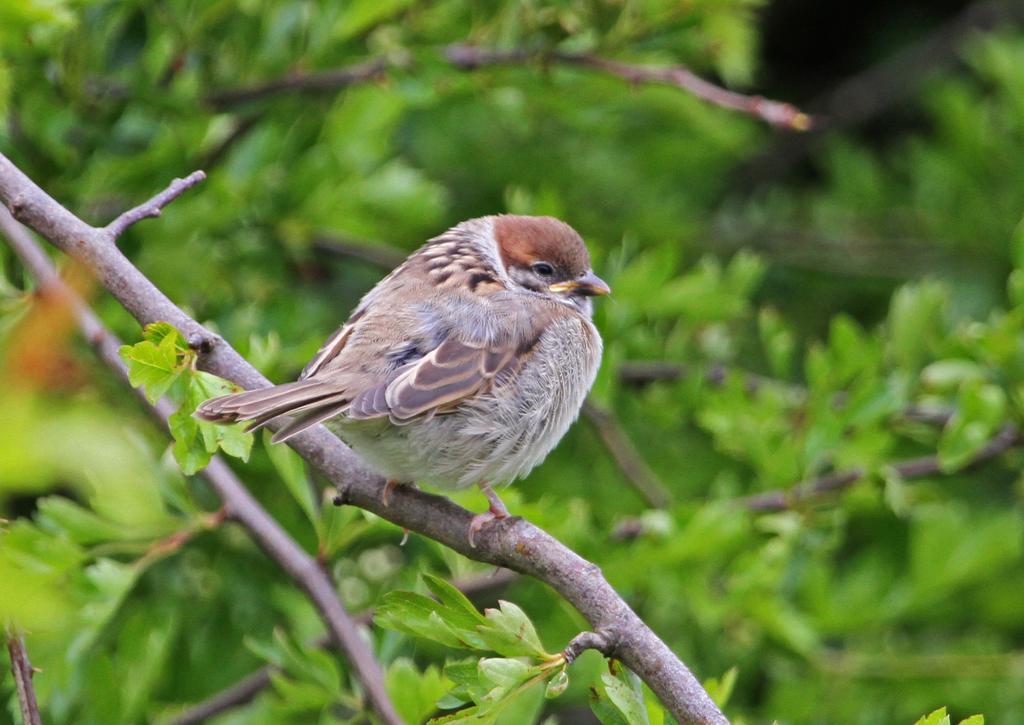What type of animal can be seen in the image? There is a bird in the image. Where is the bird located? The bird is standing on a branch of a tree. What can be seen in the background of the image? There are leaves visible in the background of the image. How would you describe the background of the image? The background appears blurry. Can you tell me how many lizards are sitting on the bird's head in the image? There are no lizards present in the image, and therefore none are sitting on the bird's head. 